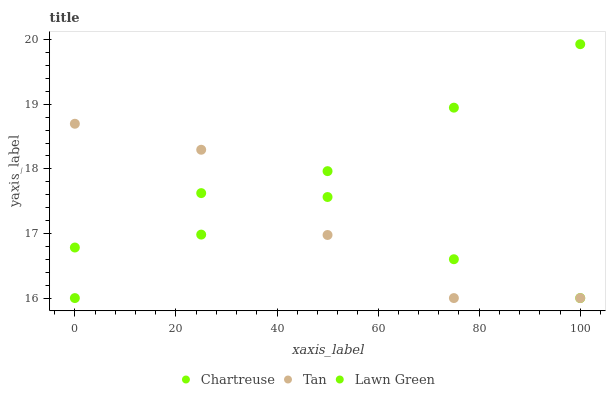Does Chartreuse have the minimum area under the curve?
Answer yes or no. Yes. Does Lawn Green have the maximum area under the curve?
Answer yes or no. Yes. Does Tan have the minimum area under the curve?
Answer yes or no. No. Does Tan have the maximum area under the curve?
Answer yes or no. No. Is Lawn Green the smoothest?
Answer yes or no. Yes. Is Tan the roughest?
Answer yes or no. Yes. Is Chartreuse the smoothest?
Answer yes or no. No. Is Chartreuse the roughest?
Answer yes or no. No. Does Lawn Green have the lowest value?
Answer yes or no. Yes. Does Lawn Green have the highest value?
Answer yes or no. Yes. Does Tan have the highest value?
Answer yes or no. No. Does Chartreuse intersect Lawn Green?
Answer yes or no. Yes. Is Chartreuse less than Lawn Green?
Answer yes or no. No. Is Chartreuse greater than Lawn Green?
Answer yes or no. No. 